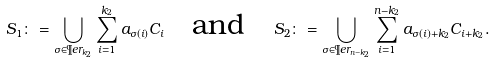Convert formula to latex. <formula><loc_0><loc_0><loc_500><loc_500>S _ { 1 } \colon = \bigcup _ { \sigma \in \P e r _ { k _ { 2 } } } \sum _ { i = 1 } ^ { k _ { 2 } } a _ { \sigma ( i ) } C _ { i } \quad \text {and} \quad S _ { 2 } \colon = \bigcup _ { \sigma \in \P e r _ { n - k _ { 2 } } } \sum _ { i = 1 } ^ { n - k _ { 2 } } a _ { \sigma ( i ) + k _ { 2 } } C _ { i + k _ { 2 } } .</formula> 